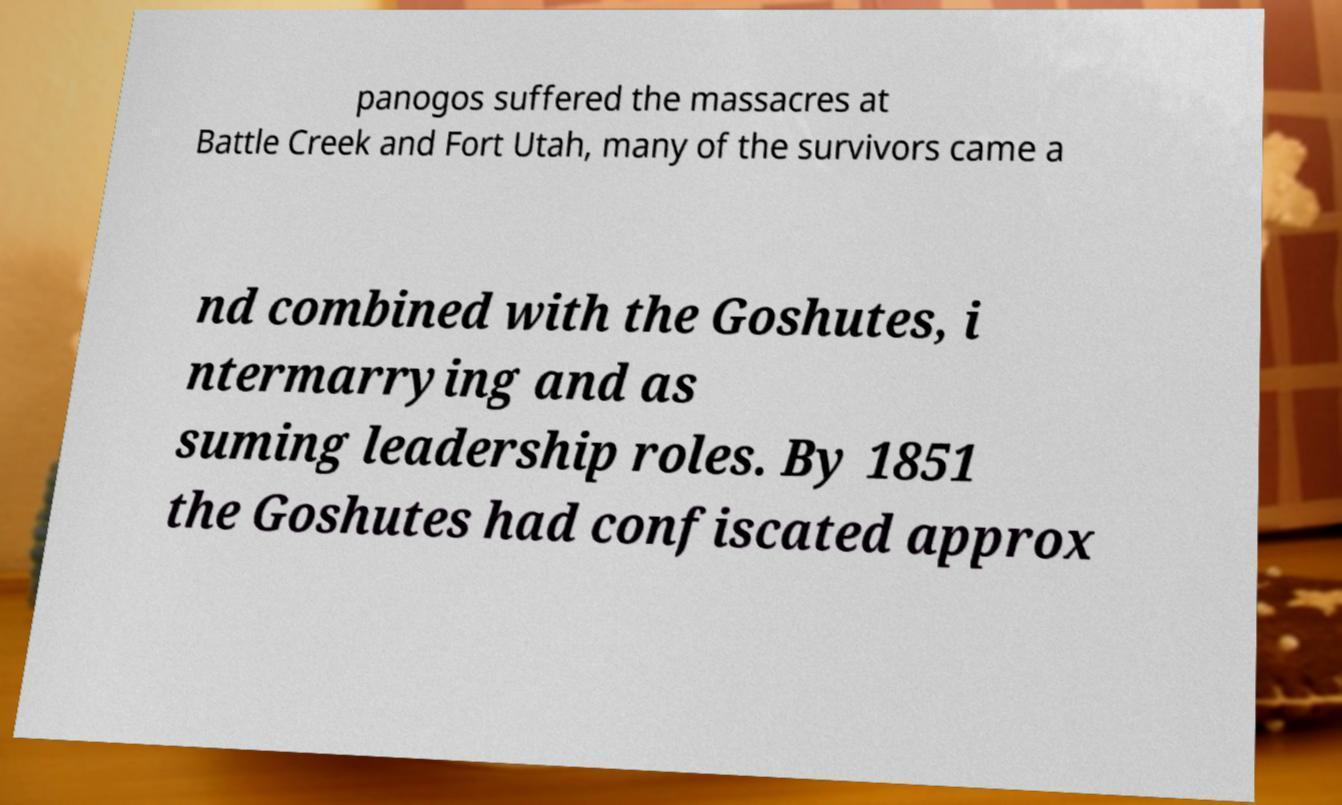There's text embedded in this image that I need extracted. Can you transcribe it verbatim? panogos suffered the massacres at Battle Creek and Fort Utah, many of the survivors came a nd combined with the Goshutes, i ntermarrying and as suming leadership roles. By 1851 the Goshutes had confiscated approx 